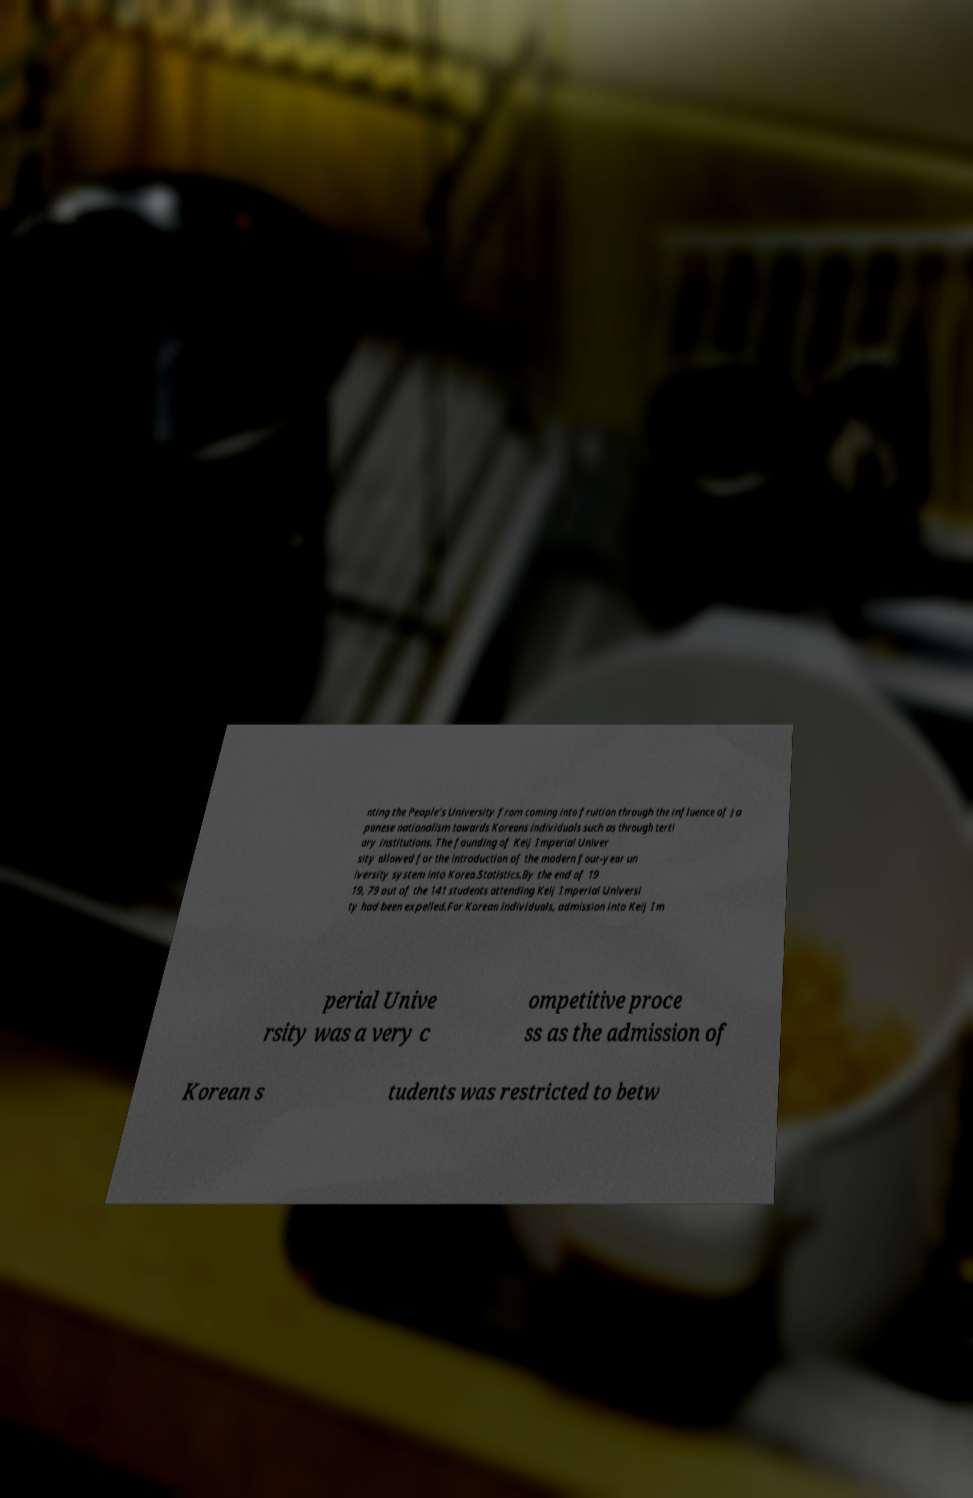There's text embedded in this image that I need extracted. Can you transcribe it verbatim? nting the People’s University from coming into fruition through the influence of Ja panese nationalism towards Koreans individuals such as through terti ary institutions. The founding of Keij Imperial Univer sity allowed for the introduction of the modern four-year un iversity system into Korea.Statistics.By the end of 19 19, 79 out of the 141 students attending Keij Imperial Universi ty had been expelled.For Korean individuals, admission into Keij Im perial Unive rsity was a very c ompetitive proce ss as the admission of Korean s tudents was restricted to betw 